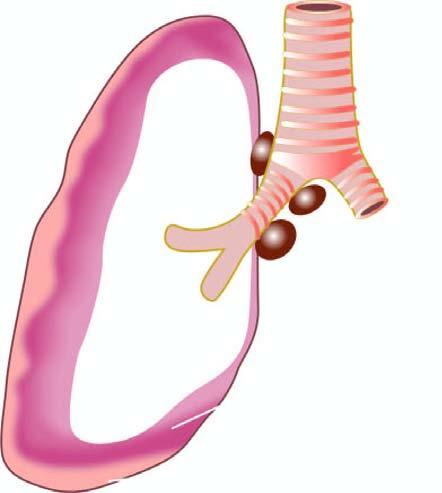what is seen to form a thick, white, fleshy coat over the parietal and visceral surfaces?
Answer the question using a single word or phrase. Tumour 